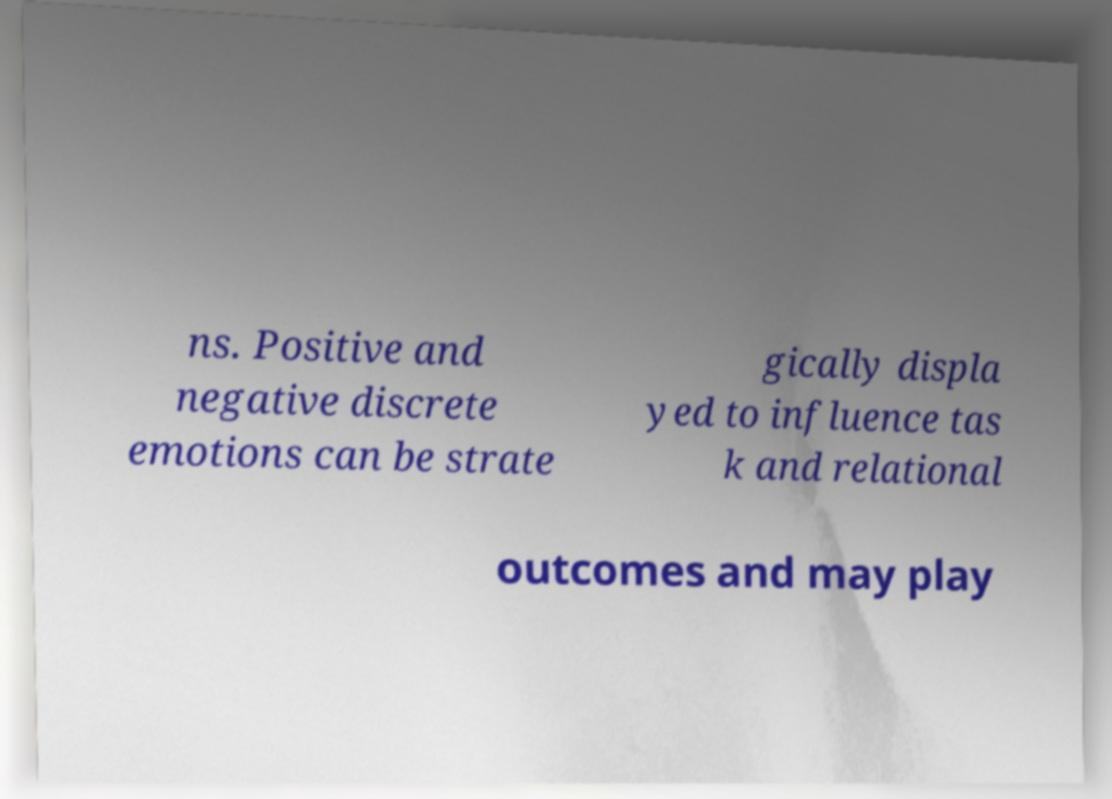There's text embedded in this image that I need extracted. Can you transcribe it verbatim? ns. Positive and negative discrete emotions can be strate gically displa yed to influence tas k and relational outcomes and may play 